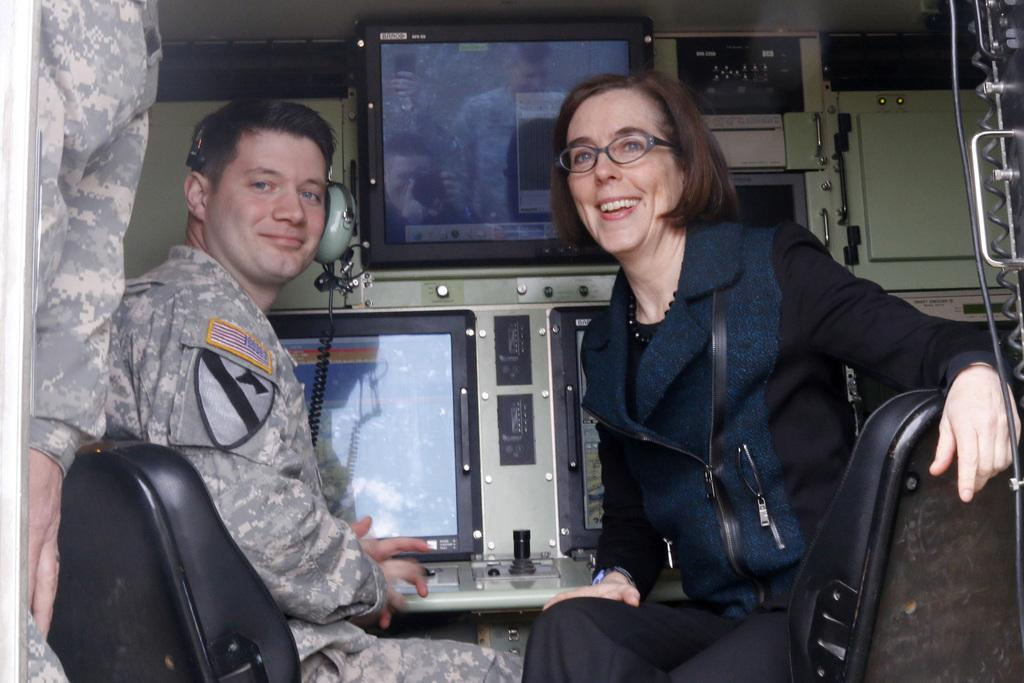How many pilots are in the image? There are two pilots in the image. What are the pilots doing in the image? The pilots are sitting on seats and posing for a photo. What is in front of the pilots? There are three screens in front of the pilots. What else can be seen in the image besides the pilots and screens? There are other machines visible in the image. What type of chain can be seen connecting the pilots in the image? There is no chain connecting the pilots in the image. 